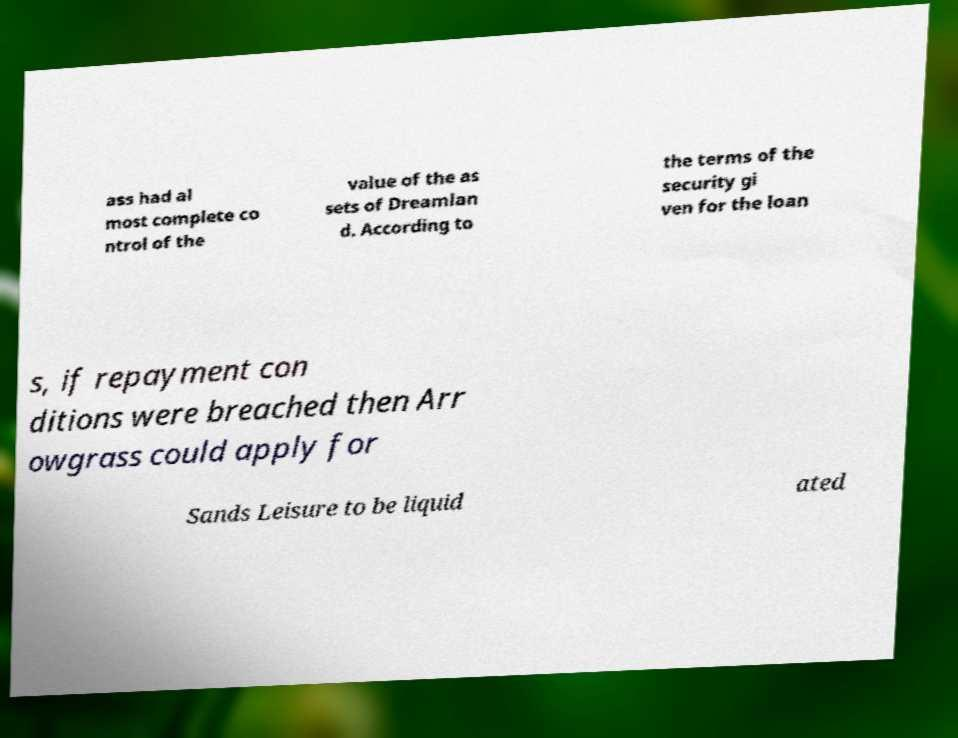Can you read and provide the text displayed in the image?This photo seems to have some interesting text. Can you extract and type it out for me? ass had al most complete co ntrol of the value of the as sets of Dreamlan d. According to the terms of the security gi ven for the loan s, if repayment con ditions were breached then Arr owgrass could apply for Sands Leisure to be liquid ated 